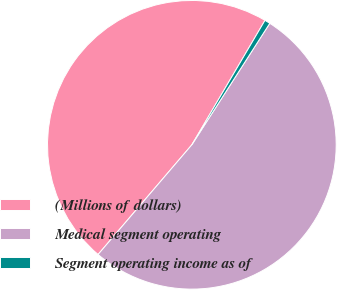Convert chart to OTSL. <chart><loc_0><loc_0><loc_500><loc_500><pie_chart><fcel>(Millions of dollars)<fcel>Medical segment operating<fcel>Segment operating income as of<nl><fcel>47.2%<fcel>52.18%<fcel>0.62%<nl></chart> 